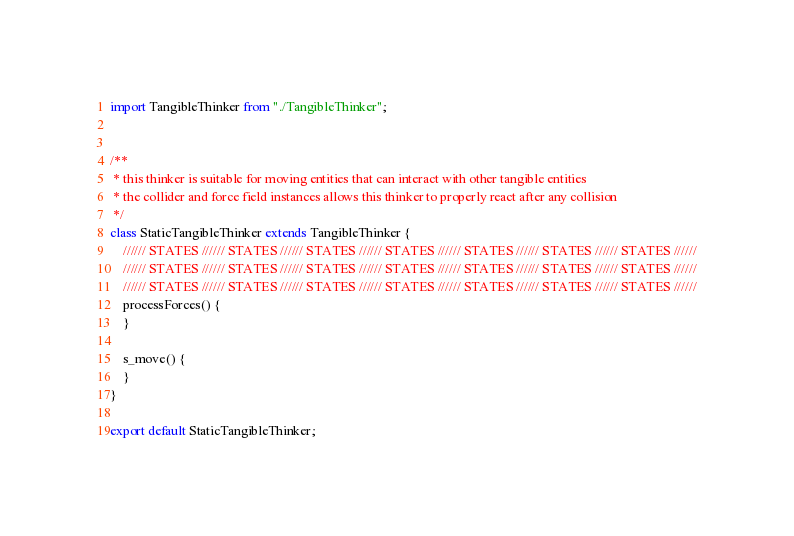Convert code to text. <code><loc_0><loc_0><loc_500><loc_500><_JavaScript_>import TangibleThinker from "./TangibleThinker";


/**
 * this thinker is suitable for moving entities that can interact with other tangible entities
 * the collider and force field instances allows this thinker to properly react after any collision
 */
class StaticTangibleThinker extends TangibleThinker {
    ////// STATES ////// STATES ////// STATES ////// STATES ////// STATES ////// STATES ////// STATES //////
    ////// STATES ////// STATES ////// STATES ////// STATES ////// STATES ////// STATES ////// STATES //////
    ////// STATES ////// STATES ////// STATES ////// STATES ////// STATES ////// STATES ////// STATES //////
    processForces() {
    }

    s_move() {
    }
}

export default StaticTangibleThinker;</code> 